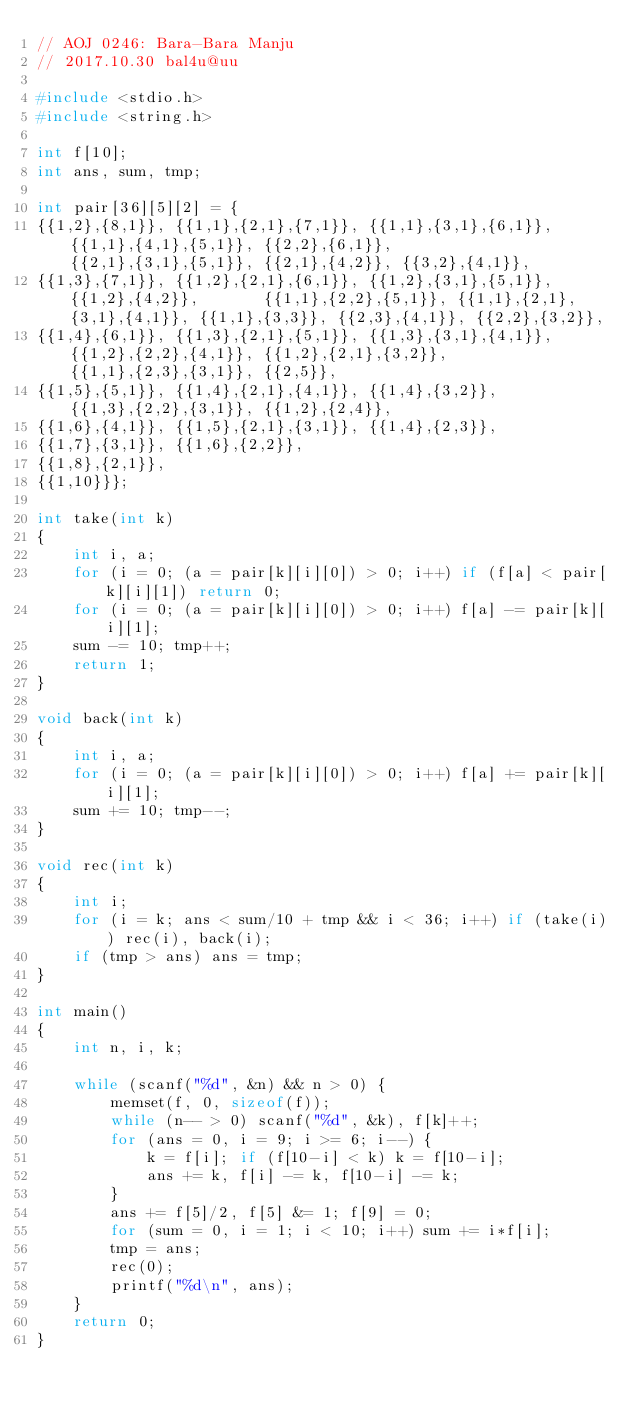<code> <loc_0><loc_0><loc_500><loc_500><_C_>// AOJ 0246: Bara-Bara Manju
// 2017.10.30 bal4u@uu

#include <stdio.h>
#include <string.h>

int f[10];
int ans, sum, tmp;

int pair[36][5][2] = {
{{1,2},{8,1}}, {{1,1},{2,1},{7,1}}, {{1,1},{3,1},{6,1}}, {{1,1},{4,1},{5,1}}, {{2,2},{6,1}},       {{2,1},{3,1},{5,1}}, {{2,1},{4,2}}, {{3,2},{4,1}}, 
{{1,3},{7,1}}, {{1,2},{2,1},{6,1}}, {{1,2},{3,1},{5,1}}, {{1,2},{4,2}},       {{1,1},{2,2},{5,1}}, {{1,1},{2,1}, {3,1},{4,1}}, {{1,1},{3,3}}, {{2,3},{4,1}}, {{2,2},{3,2}}, 
{{1,4},{6,1}}, {{1,3},{2,1},{5,1}}, {{1,3},{3,1},{4,1}}, {{1,2},{2,2},{4,1}}, {{1,2},{2,1},{3,2}}, {{1,1},{2,3},{3,1}}, {{2,5}}, 
{{1,5},{5,1}}, {{1,4},{2,1},{4,1}}, {{1,4},{3,2}},       {{1,3},{2,2},{3,1}}, {{1,2},{2,4}}, 
{{1,6},{4,1}}, {{1,5},{2,1},{3,1}}, {{1,4},{2,3}}, 
{{1,7},{3,1}}, {{1,6},{2,2}}, 
{{1,8},{2,1}}, 
{{1,10}}};

int take(int k)
{
	int i, a;
	for (i = 0; (a = pair[k][i][0]) > 0; i++) if (f[a] < pair[k][i][1]) return 0;
	for (i = 0; (a = pair[k][i][0]) > 0; i++) f[a] -= pair[k][i][1];
	sum -= 10; tmp++;
	return 1;
}

void back(int k)
{
	int i, a;
	for (i = 0; (a = pair[k][i][0]) > 0; i++) f[a] += pair[k][i][1];
	sum += 10; tmp--;
}

void rec(int k)
{
	int i;
	for (i = k; ans < sum/10 + tmp && i < 36; i++) if (take(i)) rec(i), back(i);
	if (tmp > ans) ans = tmp;
}

int main()
{
	int n, i, k;

	while (scanf("%d", &n) && n > 0) {
		memset(f, 0, sizeof(f));
		while (n-- > 0) scanf("%d", &k), f[k]++;
		for (ans = 0, i = 9; i >= 6; i--) {
			k = f[i]; if (f[10-i] < k) k = f[10-i];
			ans += k, f[i] -= k, f[10-i] -= k;
		}
		ans += f[5]/2, f[5] &= 1; f[9] = 0;
		for (sum = 0, i = 1; i < 10; i++) sum += i*f[i];
		tmp = ans;
		rec(0);
		printf("%d\n", ans);
	}
	return 0;
}</code> 